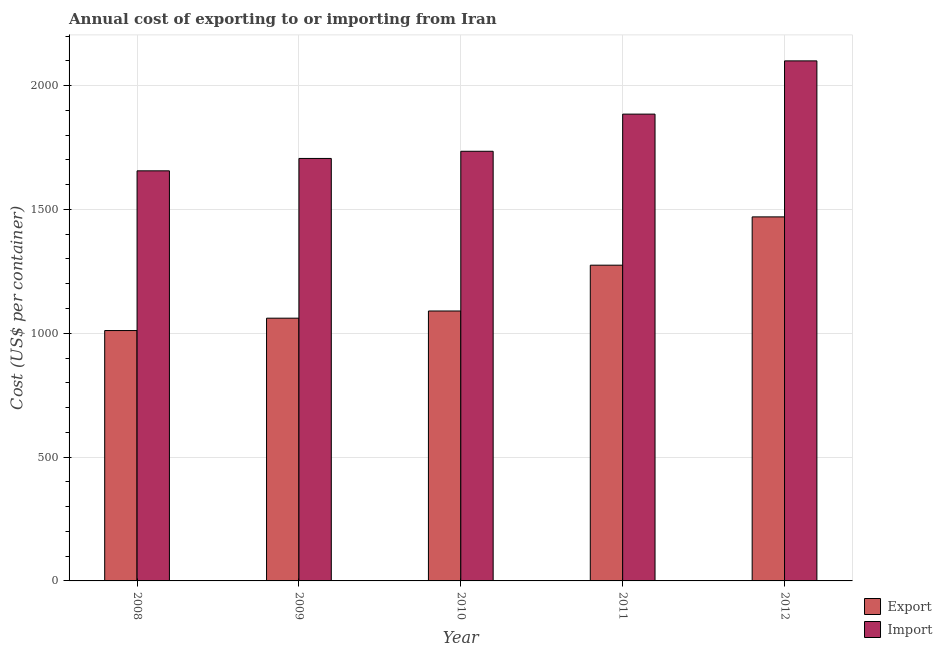How many groups of bars are there?
Your answer should be very brief. 5. Are the number of bars per tick equal to the number of legend labels?
Give a very brief answer. Yes. Are the number of bars on each tick of the X-axis equal?
Your response must be concise. Yes. How many bars are there on the 4th tick from the left?
Give a very brief answer. 2. What is the label of the 4th group of bars from the left?
Ensure brevity in your answer.  2011. In how many cases, is the number of bars for a given year not equal to the number of legend labels?
Provide a short and direct response. 0. What is the export cost in 2008?
Offer a very short reply. 1011. Across all years, what is the maximum import cost?
Your answer should be very brief. 2100. Across all years, what is the minimum export cost?
Your answer should be compact. 1011. In which year was the export cost maximum?
Make the answer very short. 2012. In which year was the export cost minimum?
Ensure brevity in your answer.  2008. What is the total import cost in the graph?
Make the answer very short. 9082. What is the difference between the import cost in 2008 and that in 2011?
Ensure brevity in your answer.  -229. What is the difference between the export cost in 2011 and the import cost in 2009?
Keep it short and to the point. 214. What is the average import cost per year?
Give a very brief answer. 1816.4. In the year 2009, what is the difference between the export cost and import cost?
Give a very brief answer. 0. What is the ratio of the import cost in 2008 to that in 2012?
Your response must be concise. 0.79. Is the difference between the export cost in 2008 and 2012 greater than the difference between the import cost in 2008 and 2012?
Give a very brief answer. No. What is the difference between the highest and the second highest export cost?
Give a very brief answer. 195. What is the difference between the highest and the lowest export cost?
Provide a succinct answer. 459. In how many years, is the export cost greater than the average export cost taken over all years?
Your answer should be very brief. 2. What does the 1st bar from the left in 2008 represents?
Ensure brevity in your answer.  Export. What does the 1st bar from the right in 2011 represents?
Your response must be concise. Import. Are all the bars in the graph horizontal?
Keep it short and to the point. No. Are the values on the major ticks of Y-axis written in scientific E-notation?
Offer a very short reply. No. Does the graph contain any zero values?
Your response must be concise. No. How many legend labels are there?
Your response must be concise. 2. What is the title of the graph?
Your response must be concise. Annual cost of exporting to or importing from Iran. Does "Birth rate" appear as one of the legend labels in the graph?
Provide a succinct answer. No. What is the label or title of the Y-axis?
Your response must be concise. Cost (US$ per container). What is the Cost (US$ per container) in Export in 2008?
Offer a terse response. 1011. What is the Cost (US$ per container) of Import in 2008?
Your response must be concise. 1656. What is the Cost (US$ per container) in Export in 2009?
Make the answer very short. 1061. What is the Cost (US$ per container) of Import in 2009?
Give a very brief answer. 1706. What is the Cost (US$ per container) of Export in 2010?
Provide a short and direct response. 1090. What is the Cost (US$ per container) of Import in 2010?
Offer a terse response. 1735. What is the Cost (US$ per container) in Export in 2011?
Give a very brief answer. 1275. What is the Cost (US$ per container) of Import in 2011?
Your response must be concise. 1885. What is the Cost (US$ per container) in Export in 2012?
Ensure brevity in your answer.  1470. What is the Cost (US$ per container) of Import in 2012?
Ensure brevity in your answer.  2100. Across all years, what is the maximum Cost (US$ per container) in Export?
Offer a terse response. 1470. Across all years, what is the maximum Cost (US$ per container) of Import?
Provide a succinct answer. 2100. Across all years, what is the minimum Cost (US$ per container) in Export?
Offer a very short reply. 1011. Across all years, what is the minimum Cost (US$ per container) of Import?
Ensure brevity in your answer.  1656. What is the total Cost (US$ per container) of Export in the graph?
Provide a short and direct response. 5907. What is the total Cost (US$ per container) in Import in the graph?
Your answer should be very brief. 9082. What is the difference between the Cost (US$ per container) in Export in 2008 and that in 2009?
Give a very brief answer. -50. What is the difference between the Cost (US$ per container) of Import in 2008 and that in 2009?
Your answer should be very brief. -50. What is the difference between the Cost (US$ per container) in Export in 2008 and that in 2010?
Your answer should be very brief. -79. What is the difference between the Cost (US$ per container) of Import in 2008 and that in 2010?
Provide a short and direct response. -79. What is the difference between the Cost (US$ per container) in Export in 2008 and that in 2011?
Provide a short and direct response. -264. What is the difference between the Cost (US$ per container) in Import in 2008 and that in 2011?
Your answer should be compact. -229. What is the difference between the Cost (US$ per container) of Export in 2008 and that in 2012?
Provide a short and direct response. -459. What is the difference between the Cost (US$ per container) in Import in 2008 and that in 2012?
Your answer should be compact. -444. What is the difference between the Cost (US$ per container) of Export in 2009 and that in 2010?
Offer a terse response. -29. What is the difference between the Cost (US$ per container) of Export in 2009 and that in 2011?
Your response must be concise. -214. What is the difference between the Cost (US$ per container) of Import in 2009 and that in 2011?
Keep it short and to the point. -179. What is the difference between the Cost (US$ per container) in Export in 2009 and that in 2012?
Give a very brief answer. -409. What is the difference between the Cost (US$ per container) in Import in 2009 and that in 2012?
Your answer should be very brief. -394. What is the difference between the Cost (US$ per container) of Export in 2010 and that in 2011?
Make the answer very short. -185. What is the difference between the Cost (US$ per container) in Import in 2010 and that in 2011?
Ensure brevity in your answer.  -150. What is the difference between the Cost (US$ per container) in Export in 2010 and that in 2012?
Give a very brief answer. -380. What is the difference between the Cost (US$ per container) in Import in 2010 and that in 2012?
Offer a terse response. -365. What is the difference between the Cost (US$ per container) in Export in 2011 and that in 2012?
Provide a short and direct response. -195. What is the difference between the Cost (US$ per container) of Import in 2011 and that in 2012?
Give a very brief answer. -215. What is the difference between the Cost (US$ per container) of Export in 2008 and the Cost (US$ per container) of Import in 2009?
Keep it short and to the point. -695. What is the difference between the Cost (US$ per container) of Export in 2008 and the Cost (US$ per container) of Import in 2010?
Ensure brevity in your answer.  -724. What is the difference between the Cost (US$ per container) of Export in 2008 and the Cost (US$ per container) of Import in 2011?
Give a very brief answer. -874. What is the difference between the Cost (US$ per container) in Export in 2008 and the Cost (US$ per container) in Import in 2012?
Give a very brief answer. -1089. What is the difference between the Cost (US$ per container) of Export in 2009 and the Cost (US$ per container) of Import in 2010?
Provide a succinct answer. -674. What is the difference between the Cost (US$ per container) of Export in 2009 and the Cost (US$ per container) of Import in 2011?
Your answer should be very brief. -824. What is the difference between the Cost (US$ per container) in Export in 2009 and the Cost (US$ per container) in Import in 2012?
Your response must be concise. -1039. What is the difference between the Cost (US$ per container) in Export in 2010 and the Cost (US$ per container) in Import in 2011?
Your answer should be very brief. -795. What is the difference between the Cost (US$ per container) in Export in 2010 and the Cost (US$ per container) in Import in 2012?
Your answer should be very brief. -1010. What is the difference between the Cost (US$ per container) of Export in 2011 and the Cost (US$ per container) of Import in 2012?
Offer a terse response. -825. What is the average Cost (US$ per container) of Export per year?
Make the answer very short. 1181.4. What is the average Cost (US$ per container) of Import per year?
Provide a succinct answer. 1816.4. In the year 2008, what is the difference between the Cost (US$ per container) of Export and Cost (US$ per container) of Import?
Your answer should be compact. -645. In the year 2009, what is the difference between the Cost (US$ per container) in Export and Cost (US$ per container) in Import?
Make the answer very short. -645. In the year 2010, what is the difference between the Cost (US$ per container) in Export and Cost (US$ per container) in Import?
Offer a very short reply. -645. In the year 2011, what is the difference between the Cost (US$ per container) in Export and Cost (US$ per container) in Import?
Your answer should be very brief. -610. In the year 2012, what is the difference between the Cost (US$ per container) in Export and Cost (US$ per container) in Import?
Your response must be concise. -630. What is the ratio of the Cost (US$ per container) of Export in 2008 to that in 2009?
Your response must be concise. 0.95. What is the ratio of the Cost (US$ per container) of Import in 2008 to that in 2009?
Give a very brief answer. 0.97. What is the ratio of the Cost (US$ per container) in Export in 2008 to that in 2010?
Provide a succinct answer. 0.93. What is the ratio of the Cost (US$ per container) of Import in 2008 to that in 2010?
Your response must be concise. 0.95. What is the ratio of the Cost (US$ per container) of Export in 2008 to that in 2011?
Give a very brief answer. 0.79. What is the ratio of the Cost (US$ per container) of Import in 2008 to that in 2011?
Offer a very short reply. 0.88. What is the ratio of the Cost (US$ per container) of Export in 2008 to that in 2012?
Provide a short and direct response. 0.69. What is the ratio of the Cost (US$ per container) in Import in 2008 to that in 2012?
Give a very brief answer. 0.79. What is the ratio of the Cost (US$ per container) of Export in 2009 to that in 2010?
Your answer should be very brief. 0.97. What is the ratio of the Cost (US$ per container) of Import in 2009 to that in 2010?
Offer a very short reply. 0.98. What is the ratio of the Cost (US$ per container) in Export in 2009 to that in 2011?
Give a very brief answer. 0.83. What is the ratio of the Cost (US$ per container) of Import in 2009 to that in 2011?
Provide a succinct answer. 0.91. What is the ratio of the Cost (US$ per container) of Export in 2009 to that in 2012?
Keep it short and to the point. 0.72. What is the ratio of the Cost (US$ per container) in Import in 2009 to that in 2012?
Ensure brevity in your answer.  0.81. What is the ratio of the Cost (US$ per container) of Export in 2010 to that in 2011?
Offer a very short reply. 0.85. What is the ratio of the Cost (US$ per container) in Import in 2010 to that in 2011?
Make the answer very short. 0.92. What is the ratio of the Cost (US$ per container) in Export in 2010 to that in 2012?
Your answer should be very brief. 0.74. What is the ratio of the Cost (US$ per container) in Import in 2010 to that in 2012?
Your answer should be very brief. 0.83. What is the ratio of the Cost (US$ per container) of Export in 2011 to that in 2012?
Your answer should be compact. 0.87. What is the ratio of the Cost (US$ per container) in Import in 2011 to that in 2012?
Your answer should be compact. 0.9. What is the difference between the highest and the second highest Cost (US$ per container) in Export?
Give a very brief answer. 195. What is the difference between the highest and the second highest Cost (US$ per container) of Import?
Keep it short and to the point. 215. What is the difference between the highest and the lowest Cost (US$ per container) in Export?
Offer a very short reply. 459. What is the difference between the highest and the lowest Cost (US$ per container) of Import?
Provide a short and direct response. 444. 